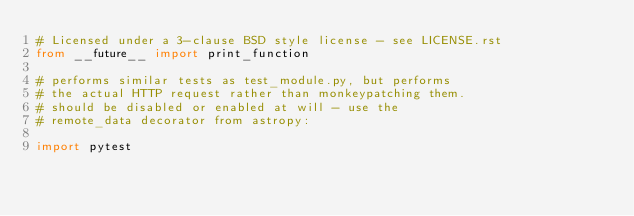Convert code to text. <code><loc_0><loc_0><loc_500><loc_500><_Python_># Licensed under a 3-clause BSD style license - see LICENSE.rst
from __future__ import print_function

# performs similar tests as test_module.py, but performs
# the actual HTTP request rather than monkeypatching them.
# should be disabled or enabled at will - use the
# remote_data decorator from astropy:

import pytest</code> 